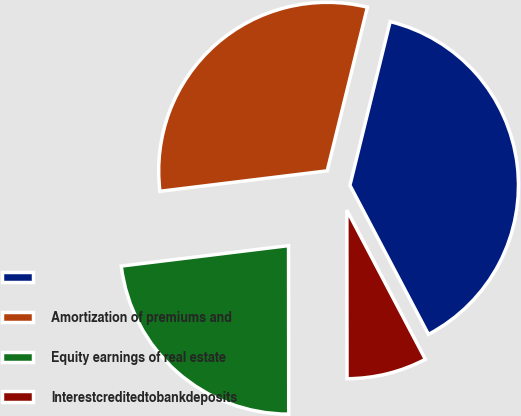Convert chart. <chart><loc_0><loc_0><loc_500><loc_500><pie_chart><ecel><fcel>Amortization of premiums and<fcel>Equity earnings of real estate<fcel>Interestcreditedtobankdeposits<nl><fcel>38.45%<fcel>30.77%<fcel>23.08%<fcel>7.7%<nl></chart> 